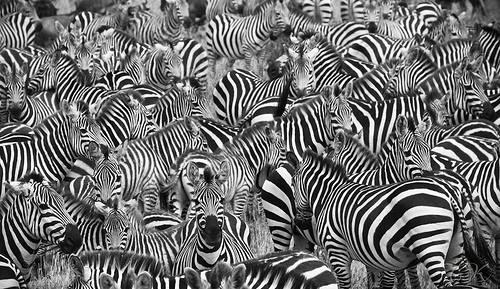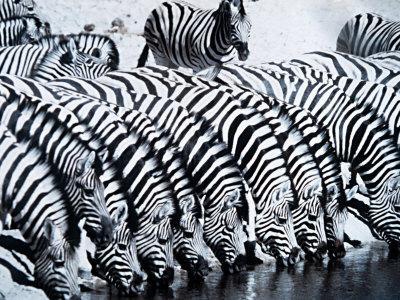The first image is the image on the left, the second image is the image on the right. For the images shown, is this caption "The right image shows zebras lined up with heads bent to the water, and the left image shows zebras en masse with nothing else in the picture." true? Answer yes or no. Yes. 